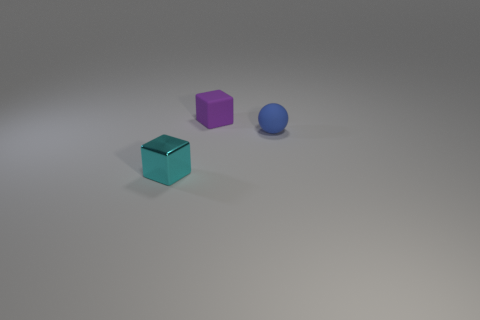There is a matte object on the right side of the tiny cube behind the small cyan metal thing; are there any tiny blue matte things that are behind it?
Your answer should be very brief. No. How many metallic objects are cyan blocks or yellow cylinders?
Provide a short and direct response. 1. Is the matte cube the same color as the metallic object?
Offer a very short reply. No. There is a small purple rubber object; how many small balls are in front of it?
Your response must be concise. 1. What number of things are left of the small blue object and in front of the tiny purple thing?
Offer a very short reply. 1. The tiny purple object that is the same material as the sphere is what shape?
Keep it short and to the point. Cube. Does the block that is behind the cyan shiny block have the same size as the cube that is in front of the blue sphere?
Provide a short and direct response. Yes. The object that is on the right side of the tiny purple block is what color?
Your answer should be very brief. Blue. What is the material of the cube that is behind the small block in front of the matte ball?
Provide a short and direct response. Rubber. What is the shape of the blue object?
Keep it short and to the point. Sphere. 